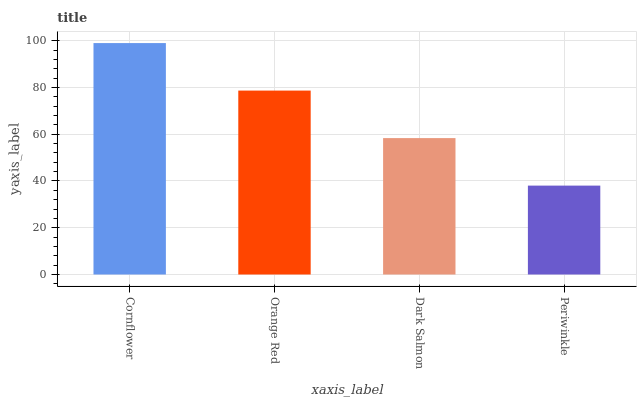Is Periwinkle the minimum?
Answer yes or no. Yes. Is Cornflower the maximum?
Answer yes or no. Yes. Is Orange Red the minimum?
Answer yes or no. No. Is Orange Red the maximum?
Answer yes or no. No. Is Cornflower greater than Orange Red?
Answer yes or no. Yes. Is Orange Red less than Cornflower?
Answer yes or no. Yes. Is Orange Red greater than Cornflower?
Answer yes or no. No. Is Cornflower less than Orange Red?
Answer yes or no. No. Is Orange Red the high median?
Answer yes or no. Yes. Is Dark Salmon the low median?
Answer yes or no. Yes. Is Periwinkle the high median?
Answer yes or no. No. Is Periwinkle the low median?
Answer yes or no. No. 